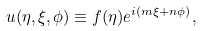Convert formula to latex. <formula><loc_0><loc_0><loc_500><loc_500>u ( \eta , \xi , \phi ) \equiv f ( \eta ) e ^ { i ( m \xi + n \phi ) } ,</formula> 